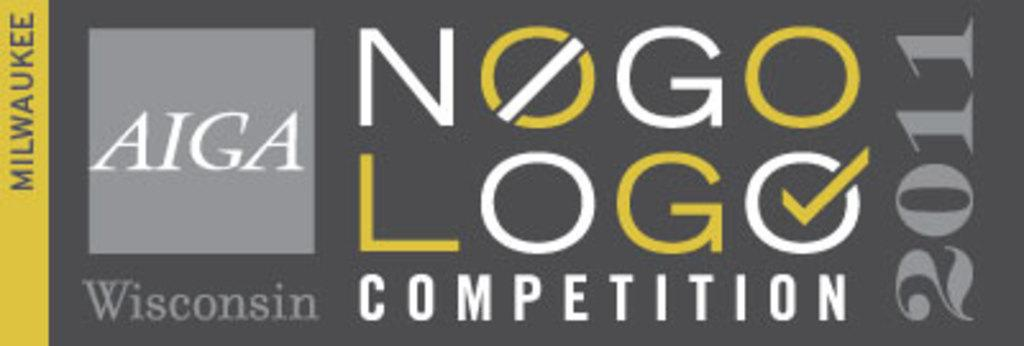What is present on the poster in the image? There is a poster in the image. What can be found on the poster besides the image? There is text and numbers on the poster. What type of grass can be seen growing on the poster in the image? There is no grass present on the poster in the image; it only contains text and numbers. 